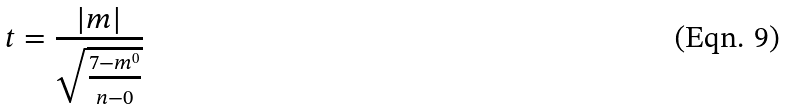Convert formula to latex. <formula><loc_0><loc_0><loc_500><loc_500>t = \frac { | m | } { \sqrt { \frac { 7 - m ^ { 0 } } { n - 0 } } }</formula> 